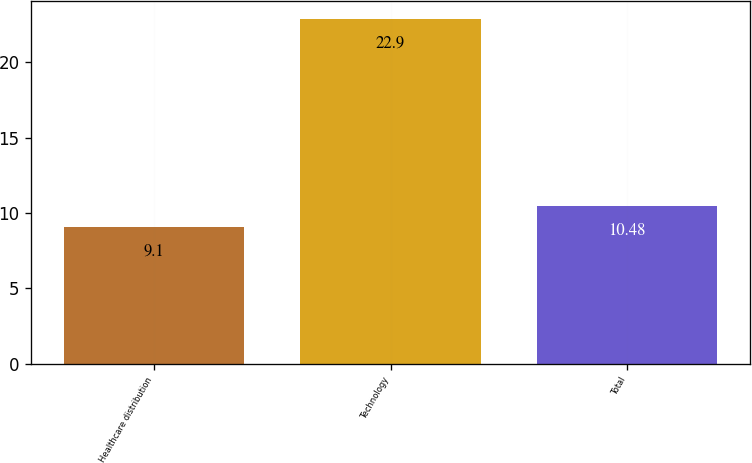Convert chart. <chart><loc_0><loc_0><loc_500><loc_500><bar_chart><fcel>Healthcare distribution<fcel>Technology<fcel>Total<nl><fcel>9.1<fcel>22.9<fcel>10.48<nl></chart> 